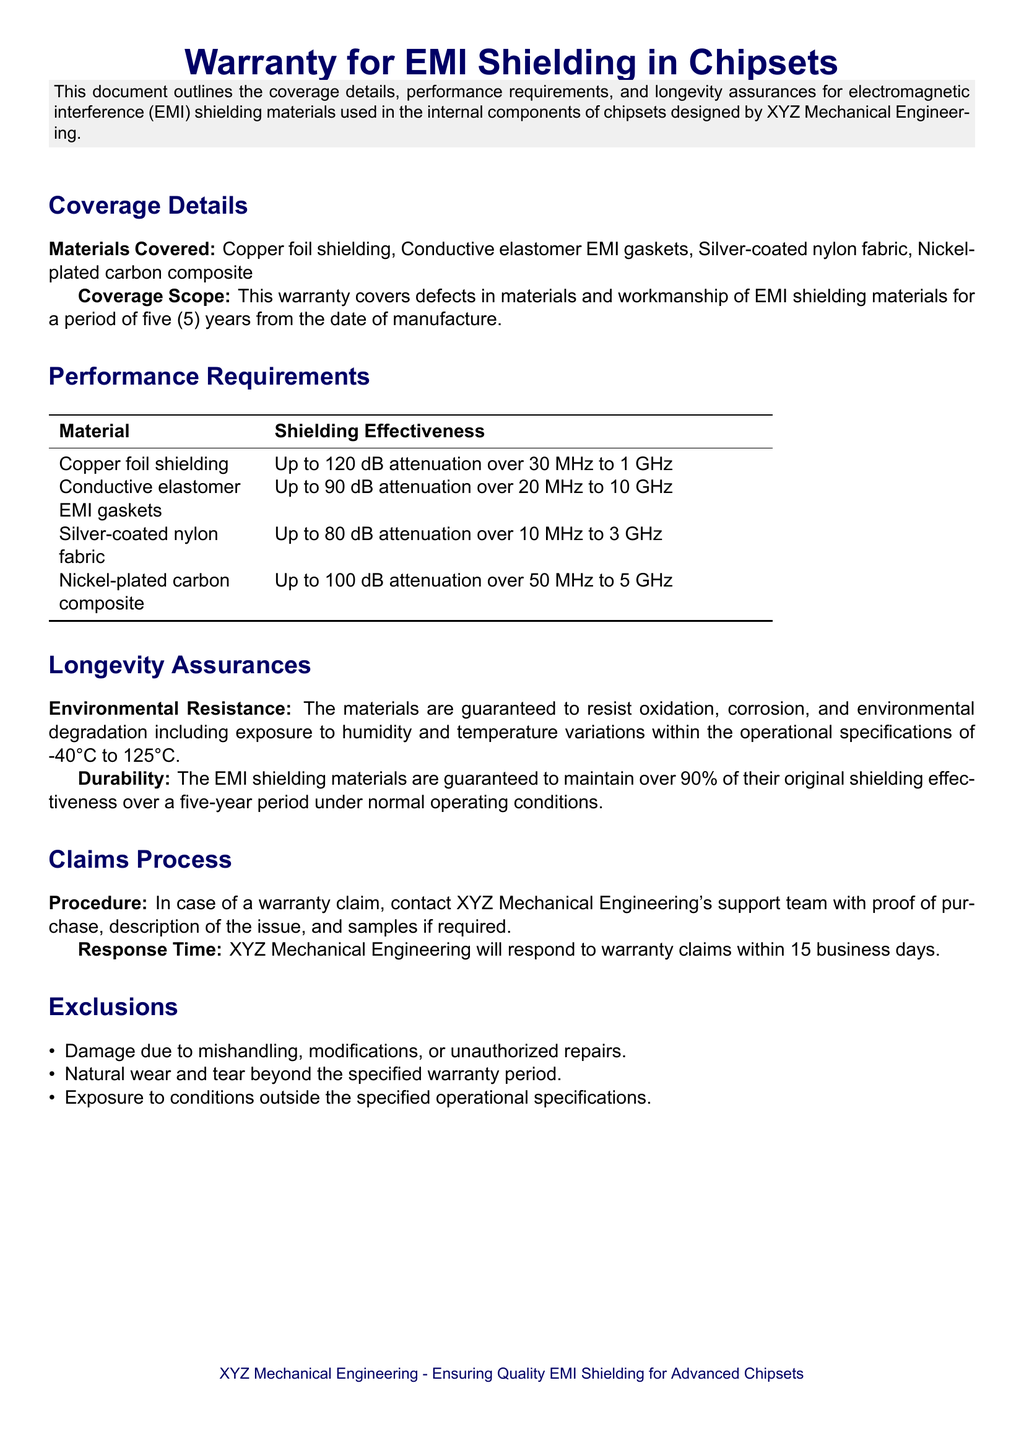What is the warranty period for EMI shielding materials? The warranty period for EMI shielding materials is stated in the document as five (5) years from the date of manufacture.
Answer: five (5) years What materials are covered under the warranty? The document lists the specific materials that are covered, including Copper foil shielding, Conductive elastomer EMI gaskets, Silver-coated nylon fabric, and Nickel-plated carbon composite.
Answer: Copper foil shielding, Conductive elastomer EMI gaskets, Silver-coated nylon fabric, Nickel-plated carbon composite What is the shielding effectiveness of copper foil shielding? The shielding effectiveness for copper foil shielding is provided, indicating it has up to 120 dB attenuation over the frequency range of 30 MHz to 1 GHz.
Answer: Up to 120 dB What environmental conditions do the materials resist? The document specifies that the materials resist oxidation, corrosion, and environmental degradation including exposure to humidity and temperature variations.
Answer: oxidation, corrosion, and environmental degradation What percentage of original shielding effectiveness is guaranteed after five years? The longevity assurances state that the EMI shielding materials are guaranteed to maintain over 90% of their original shielding effectiveness.
Answer: over 90% What is the response time for warranty claims? The document mentions the response time for warranty claims, indicating a commitment to respond within 15 business days.
Answer: 15 business days What types of damage are excluded from the warranty? The document lists exclusions, including damage due to mishandling, modifications, or unauthorized repairs.
Answer: mishandling, modifications, or unauthorized repairs What is the operational temperature range covered by the warranty? The operational specifications mentioned in the document provide a temperature range of -40°C to 125°C for the materials.
Answer: -40°C to 125°C What does the claims procedure require from the customer? The claims procedure outlined in the document requires the customer to provide proof of purchase, description of the issue, and samples if required.
Answer: proof of purchase, description of the issue, and samples if required 